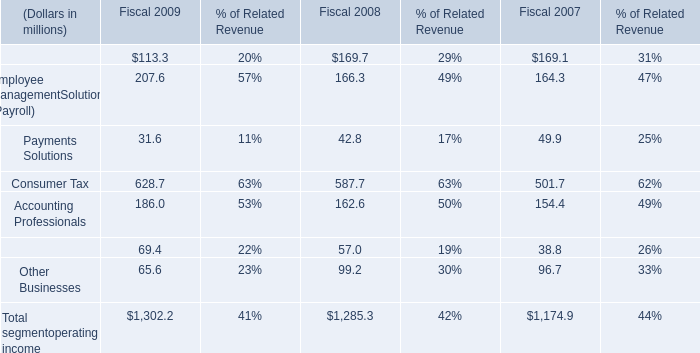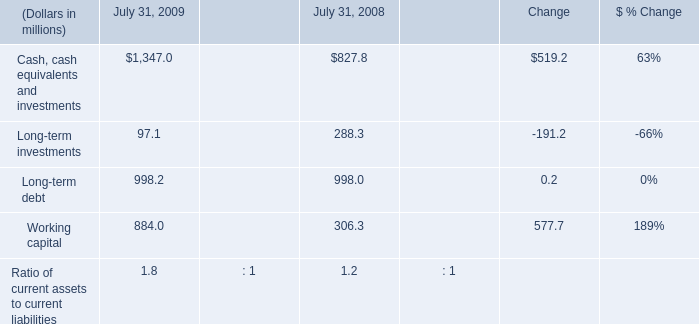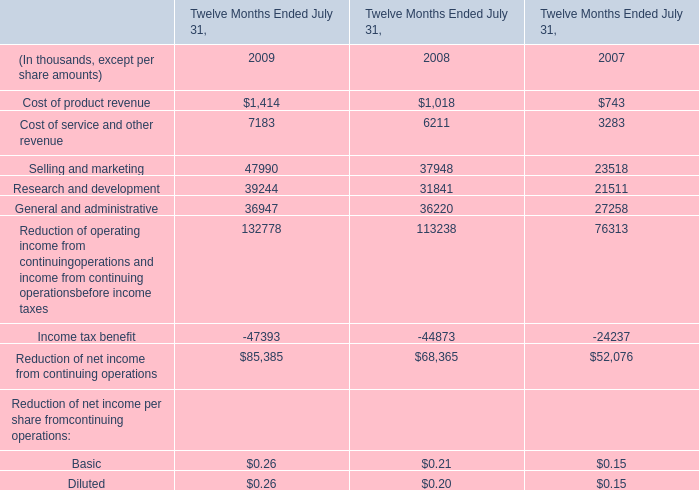In the year with lowest amount of Payments Solutions , what's the increasing rate of Accounting Professionals? 
Computations: ((162.6 - 154.4) / 154.4)
Answer: 0.05311. 